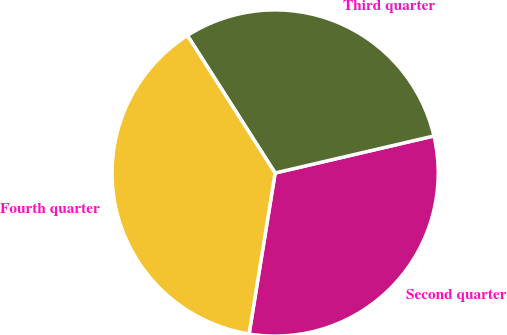Convert chart to OTSL. <chart><loc_0><loc_0><loc_500><loc_500><pie_chart><fcel>Second quarter<fcel>Third quarter<fcel>Fourth quarter<nl><fcel>31.2%<fcel>30.39%<fcel>38.41%<nl></chart> 